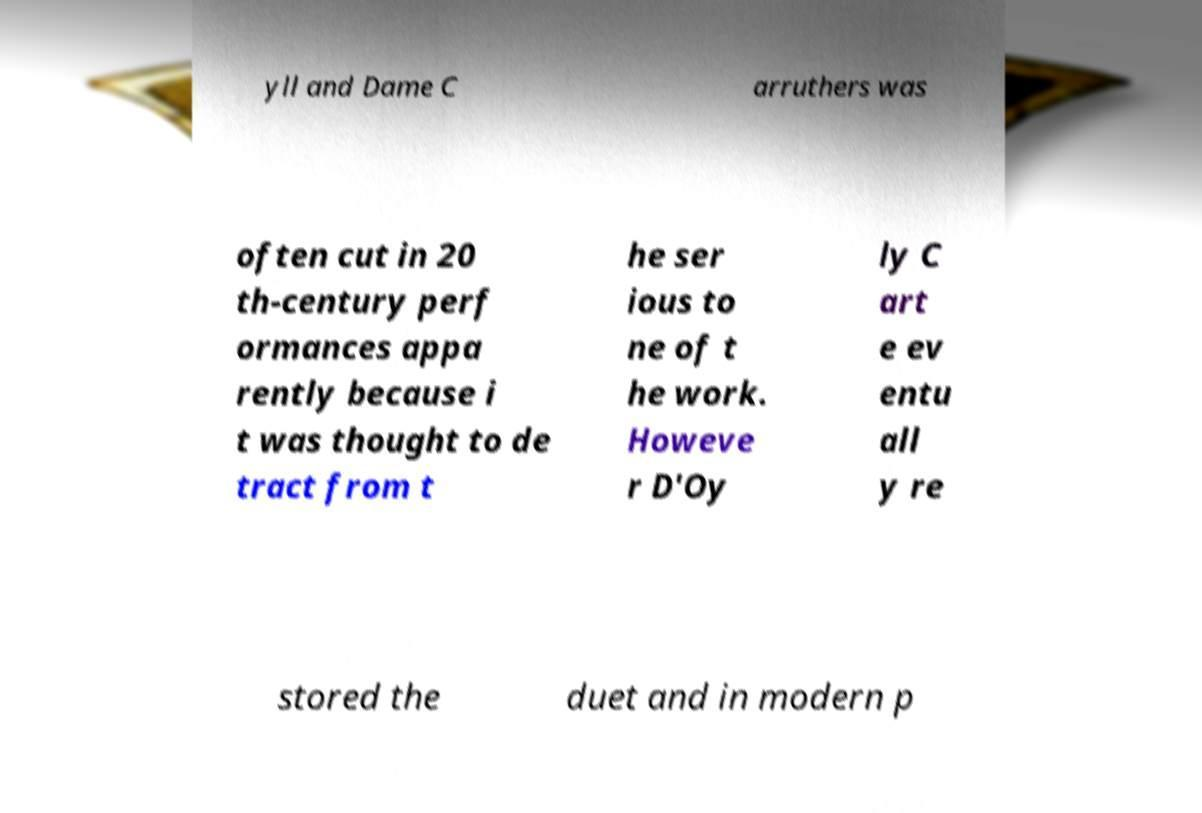What messages or text are displayed in this image? I need them in a readable, typed format. yll and Dame C arruthers was often cut in 20 th-century perf ormances appa rently because i t was thought to de tract from t he ser ious to ne of t he work. Howeve r D'Oy ly C art e ev entu all y re stored the duet and in modern p 